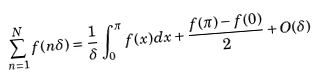Convert formula to latex. <formula><loc_0><loc_0><loc_500><loc_500>\sum ^ { N } _ { n = 1 } f ( n \delta ) = \frac { 1 } { \delta } \int ^ { \pi } _ { 0 } f ( x ) d x + \frac { f ( \pi ) - f ( 0 ) } { 2 } + O ( \delta )</formula> 